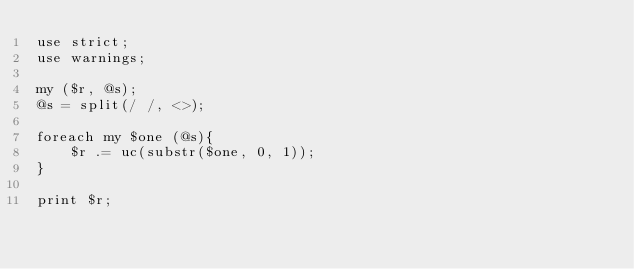Convert code to text. <code><loc_0><loc_0><loc_500><loc_500><_Perl_>use strict;
use warnings;

my ($r, @s);
@s = split(/ /, <>);

foreach my $one (@s){
	$r .= uc(substr($one, 0, 1));
}

print $r;
</code> 